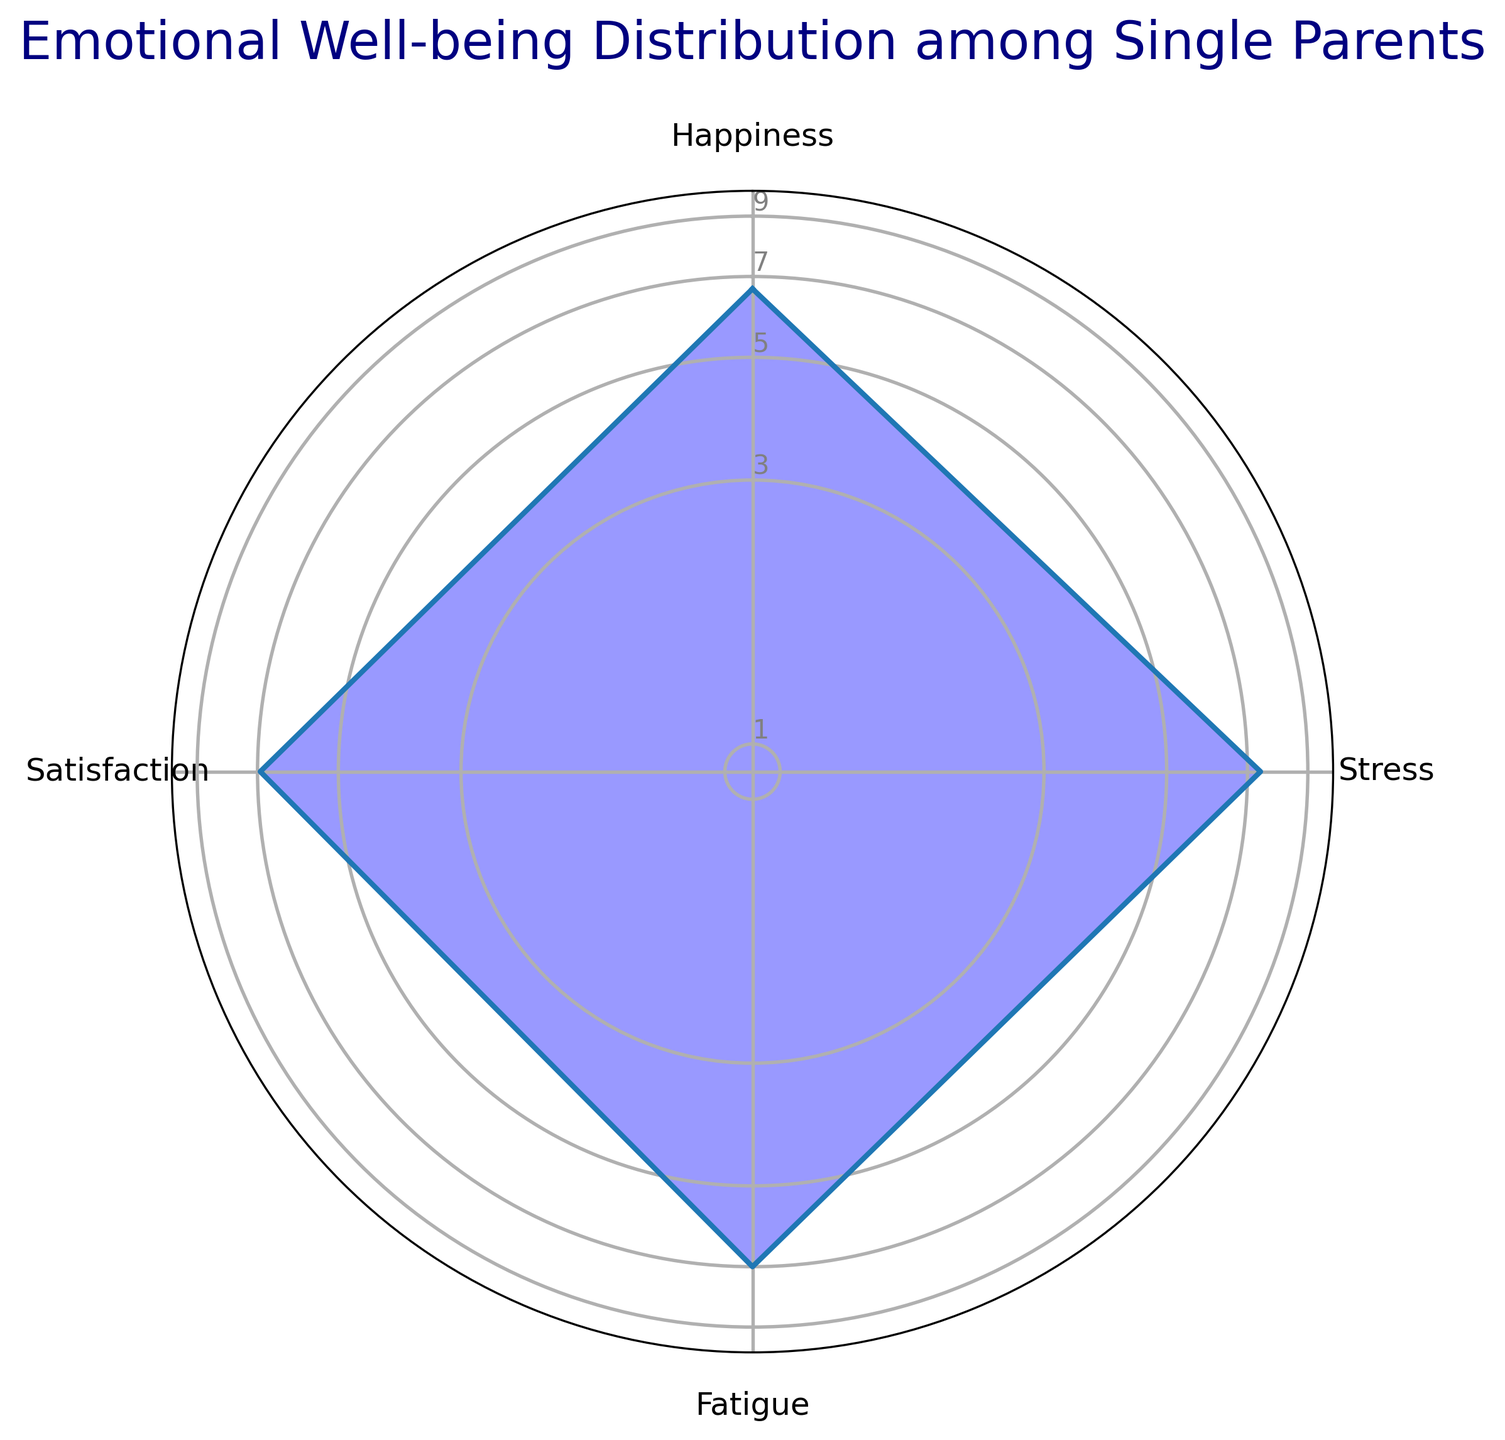What is the average level of happiness among single parents according to the radar chart? To find the average level of happiness, combine all happiness values and divide by the number of observations. Summing up the happiness values (6.5 + 7 + 5.8 + 6 + 7.2 + 6.5 + 6.8 + 7 + 6.2 + 7.5) gives 66.5. Divide this sum by the number of observations (10) to get the average.
Answer: 6.65 How does the average level of stress compare to the average level of happiness? Calculate the average stress level, which is the sum of stress values divided by the number of observations. Summing stress values (8 + 7.5 + 8.2 + 7 + 6.8 + 7.5 + 7.2 + 6.5 + 8 + 7.2) gives 74.9. Divide this by 10 to get 7.49. Compare it with the average happiness level of 6.65.
Answer: Stress is higher Which emotional factor has the highest average value? Calculate the average for each emotional factor. Happiness (6.65), Stress (7.49), Fatigue (7.03), and Satisfaction (6.82). Compare the averages to determine the highest one.
Answer: Stress Is the level of satisfaction generally higher or lower than the level of fatigue among single parents? Compare the average values of satisfaction (6.82) and fatigue (7.03).
Answer: Lower What is the range of the stress levels depicted in the radar chart? The range is the difference between the maximum and minimum values. Maximum stress level is 8.2, minimum is 6.5. Subtract minimum from maximum to find the range.
Answer: 1.7 How does the variance in stress levels compare to the variance in happiness levels? Variance measures how far each number in the dataset is from the mean. Visually analyze the spread of the values around the average for both stress and happiness. Since the stress levels vary more noticeably, the variance for stress is higher.
Answer: Higher for stress By how much does the average happiness level deviate from the midpoint of the scale (5)? Subtract the average happiness level from the midpoint (5). The average happiness is 6.65, so the deviation is 6.65 - 5.
Answer: 1.65 How many emotional factors have an average value greater than 7? Compare the average values of each factor: Happiness (6.65), Stress (7.49), Fatigue (7.03), and Satisfaction (6.82). Count how many are above 7.
Answer: 2 Which emotional factor shows the least variation around its average according to the radar chart? Visually inspect the graphical representation of each factor and observe the closeness of the plotted value points to their lines of averages. Fatigue and Satisfaction show less visually noticeable variation.
Answer: Satisfaction Based on the radar chart, is the overall emotional well-being of single parents more aligned with fatigue or happiness? Compare the closeness of the average lines and the overall spread of values for both fatigue and happiness. Since both tend to have similar average trends with slightly less variation in happiness, report the closer alignment.
Answer: Happiness 